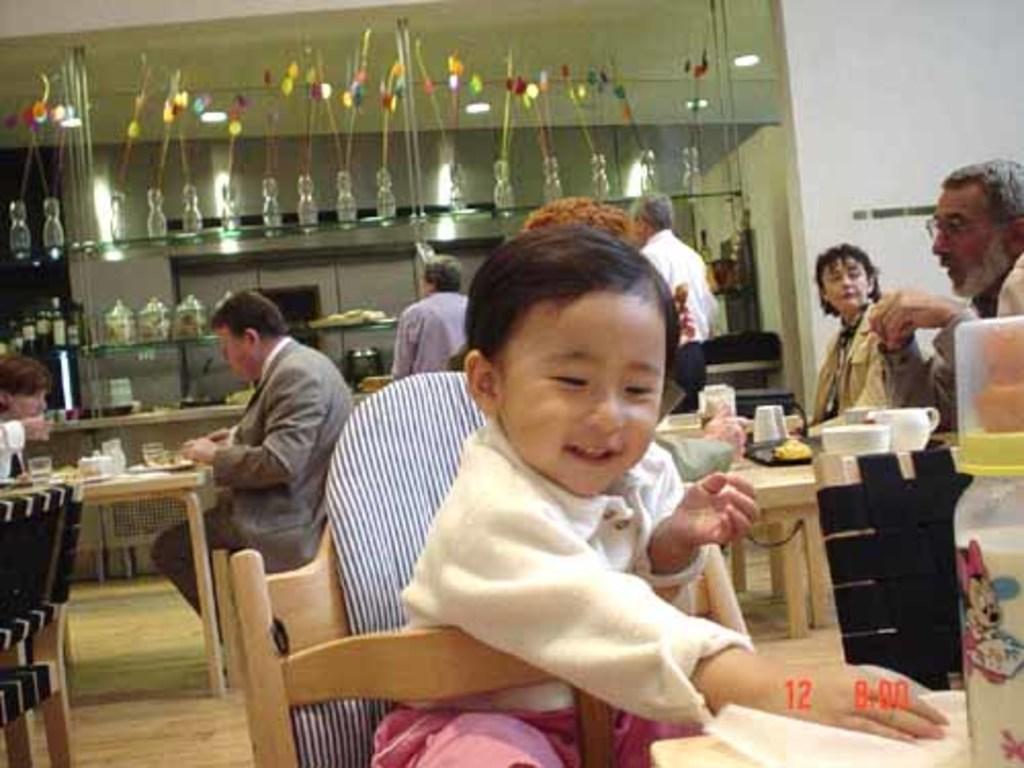In one or two sentences, can you explain what this image depicts? This picture is clicked inside a restaurant. There are tables and chairs in the image. There few people sitting on chairs at the table. In the center there is a kid siting on chair and in front of there is table and on it there is bottle. On the table at the right corner there are cups, glasses, trays and food. In the background there are shelves and in the shelves there are vases, jars and food. 